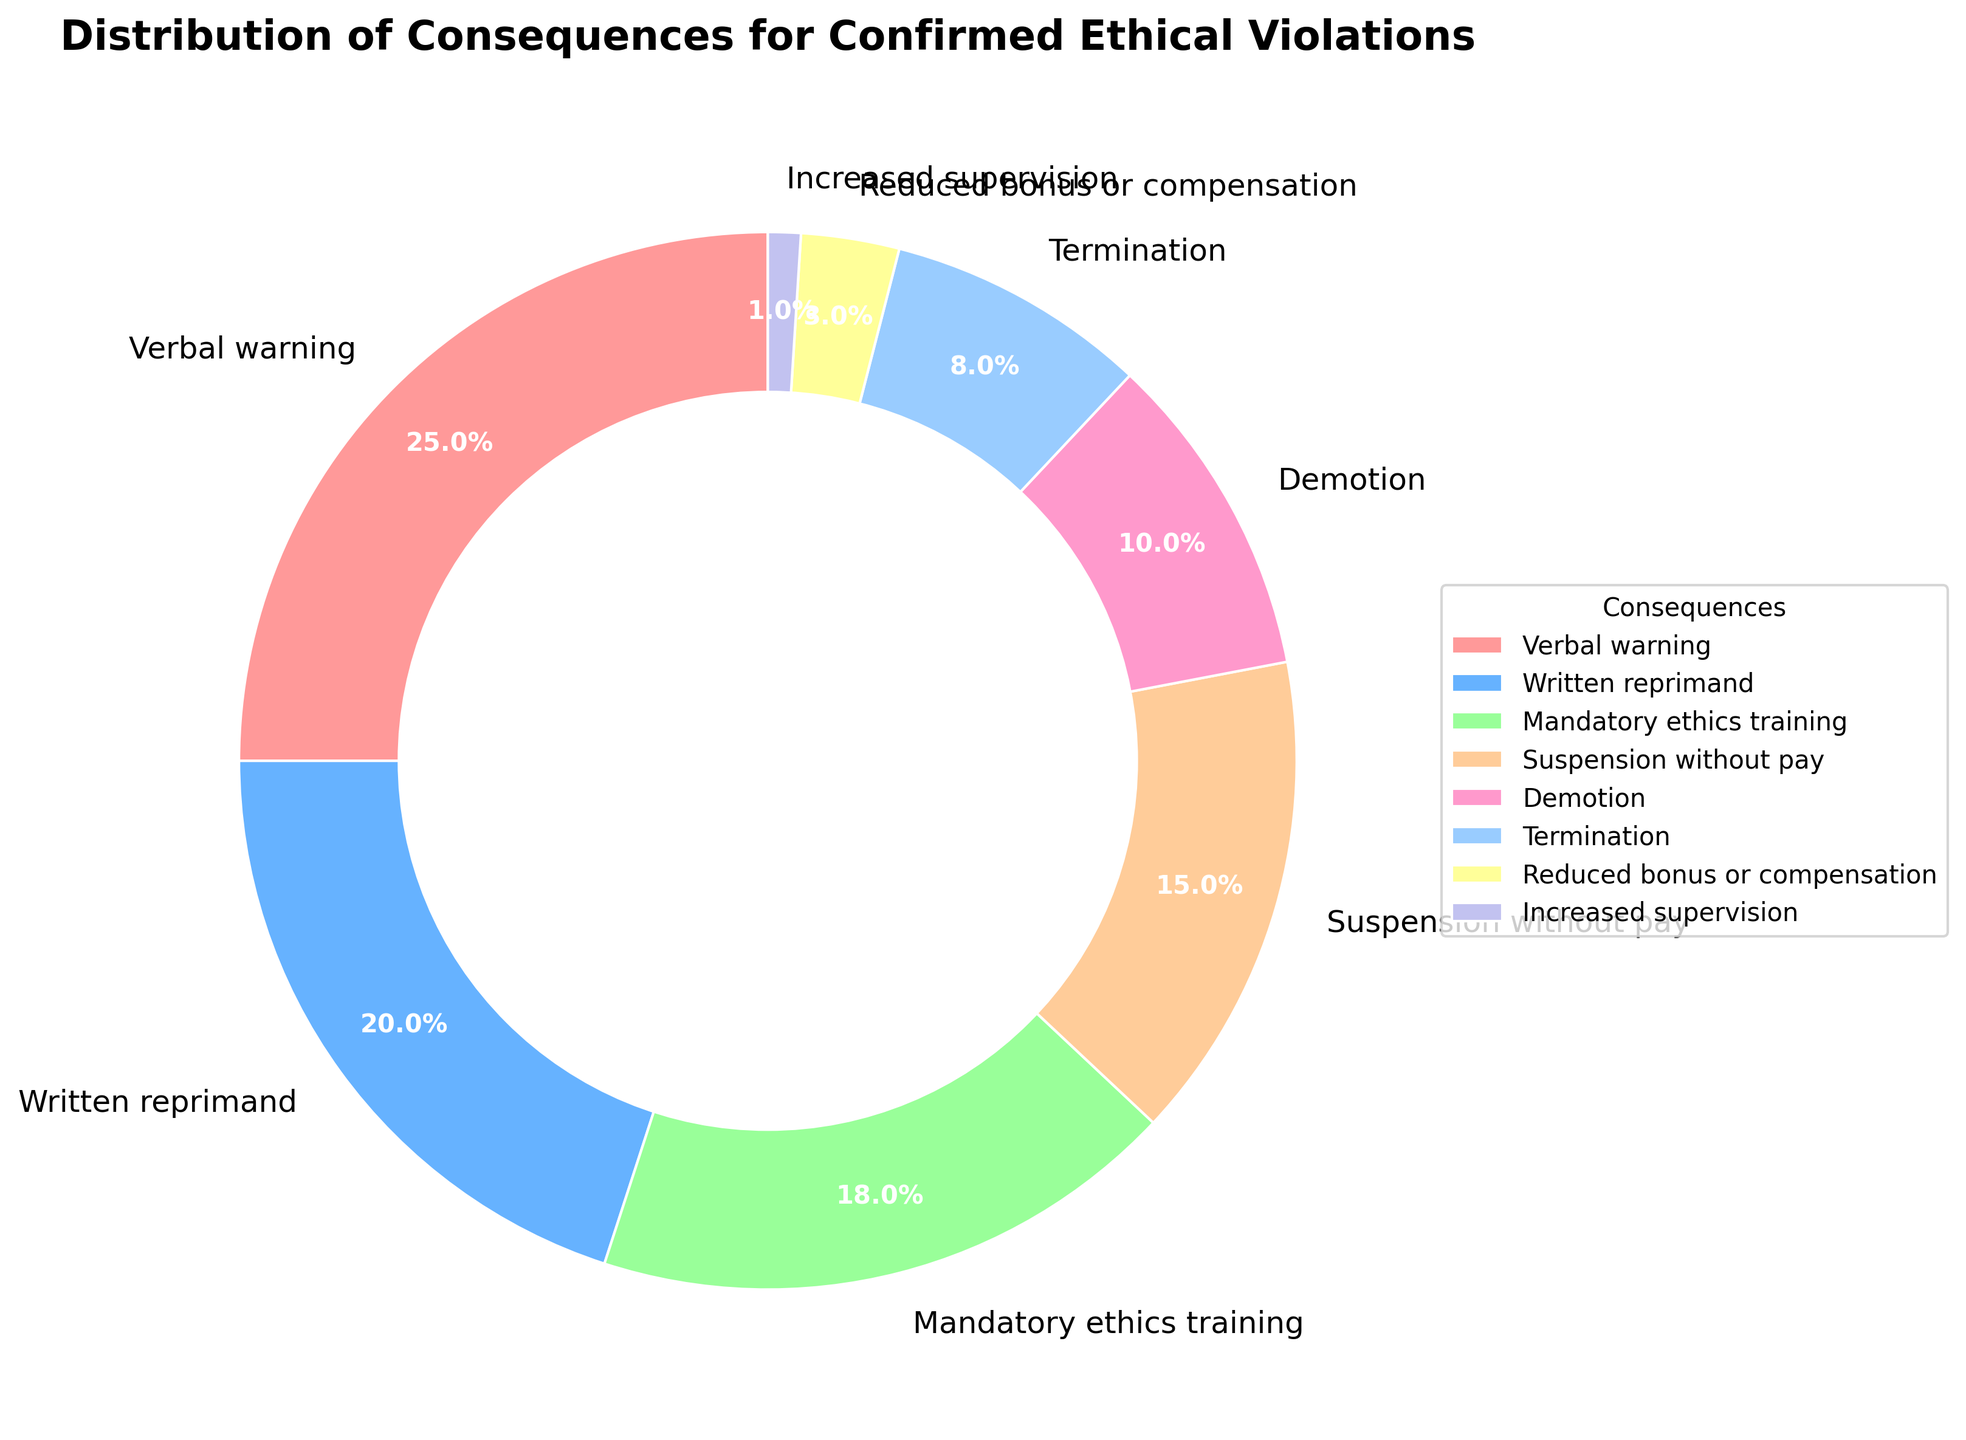What percentage of consequences involve some form of training or supervision? To find this, we need to sum the percentages associated with "Mandatory ethics training" and "Increased supervision." Mandatory ethics training is 18%, and increased supervision is 1%, so the total is 18% + 1%.
Answer: 19% Which consequence has the highest percentage? In the figure, the largest slice is labeled "Verbal warning" with a percentage of 25%. Therefore, the consequence with the highest percentage is a verbal warning.
Answer: Verbal warning What is the combined percentage for consequences involving documentation (verbal warning, written reprimand)? The percentages for verbal warning and written reprimand are 25% and 20%, respectively. Adding these together gives us 25% + 20%.
Answer: 45% Which has a higher percentage: suspension without pay or reduced bonus or compensation? By looking at the figure, suspension without pay accounts for 15%, while reduced bonus or compensation accounts for 3%. Hence, suspension without pay has a higher percentage.
Answer: Suspension without pay How much higher is the percentage of verbal warnings compared to demotions? The percentage for verbal warnings is 25%, and for demotions, it is 10%. The difference is calculated as 25% - 10%.
Answer: 15% Which consequence has the smallest percentage? The smallest slice in the figure corresponds to "Increased supervision" with a percentage of 1%.
Answer: Increased supervision Between written reprimand and termination, which consequence has a higher percentage and by how much? Written reprimand has a percentage of 20%, while termination has 8%. The difference between them is calculated as 20% - 8%.
Answer: Written reprimand by 12% What is the average percentage of all consequences listed? There are eight consequence categories, and their total percentage is 25% + 20% + 18% + 15% + 10% + 8% + 3% + 1% = 100%. The average is calculated as 100% / 8.
Answer: 12.5% Does mandatory ethics training have a higher percentage than demotion? Mandatory ethics training is 18%, while demotion is 10%. Therefore, mandatory ethics training has a higher percentage than demotion.
Answer: Yes 